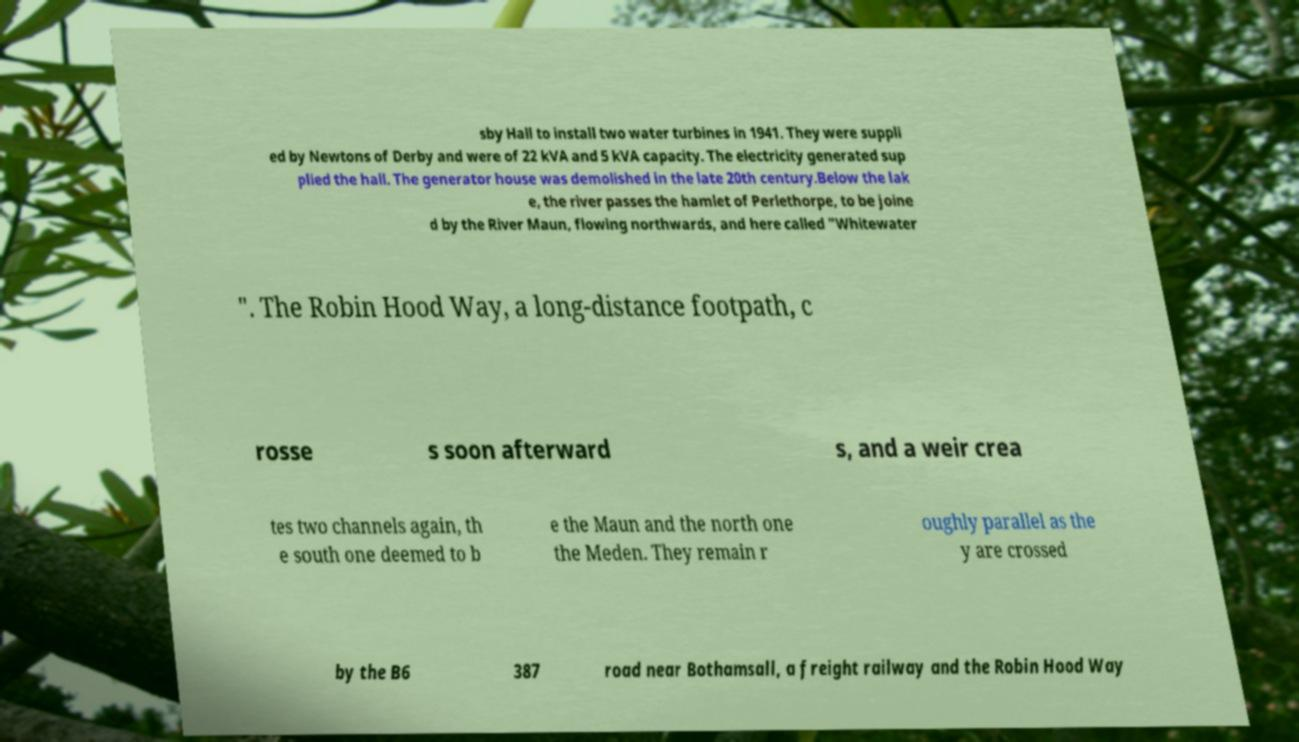For documentation purposes, I need the text within this image transcribed. Could you provide that? sby Hall to install two water turbines in 1941. They were suppli ed by Newtons of Derby and were of 22 kVA and 5 kVA capacity. The electricity generated sup plied the hall. The generator house was demolished in the late 20th century.Below the lak e, the river passes the hamlet of Perlethorpe, to be joine d by the River Maun, flowing northwards, and here called "Whitewater ". The Robin Hood Way, a long-distance footpath, c rosse s soon afterward s, and a weir crea tes two channels again, th e south one deemed to b e the Maun and the north one the Meden. They remain r oughly parallel as the y are crossed by the B6 387 road near Bothamsall, a freight railway and the Robin Hood Way 